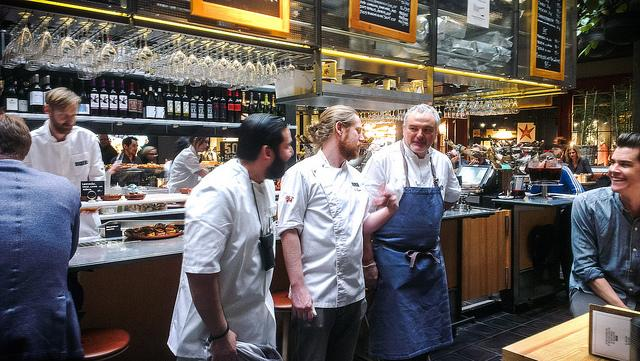What profession are the men wearing aprons?

Choices:
A) janitors
B) artists
C) cooks
D) repairmen cooks 